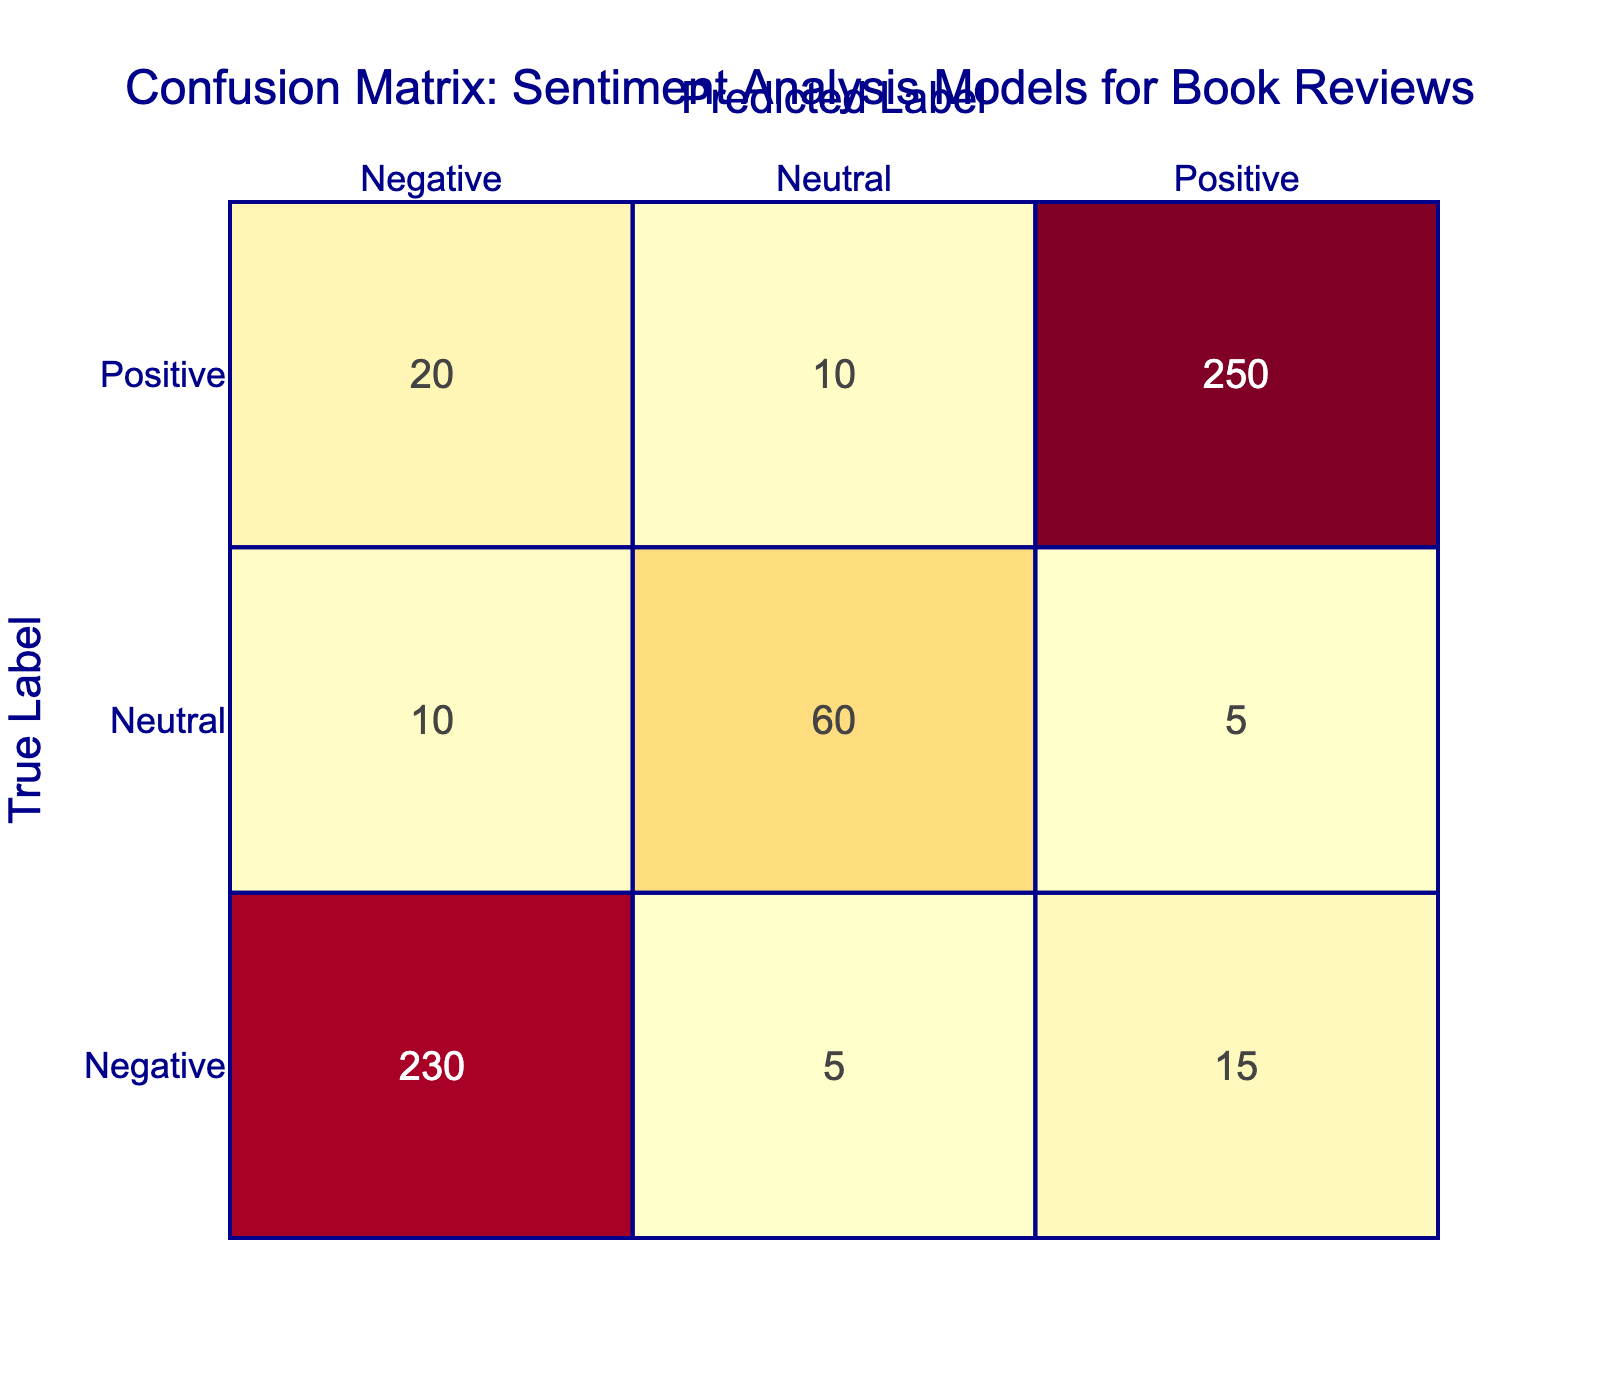What is the total number of positive predictions made? To find the total number of positive predictions, we sum the counts of all predictions labeled as positive across all true labels. This includes the counts for Positive as Positive (250), Negative as Positive (15), and Neutral as Positive (5). Therefore, the calculation is 250 + 15 + 5 = 270.
Answer: 270 How many reviews were predicted as Negative? To find the total number of reviews predicted as Negative, we sum the counts of all rows labeled as Negative in the Predicted Label column. This includes Negative as Negative (230), Positive as Negative (20), and Neutral as Negative (10). The sum is 230 + 20 + 10 = 260.
Answer: 260 What is the count of Neutral reviews that were correctly predicted? The correctly predicted Neutral reviews refer to the count where the True Label is Neutral and the Predicted Label is also Neutral. Referring to the table, this count is directly shown as 60.
Answer: 60 Is the count of Negative predictions greater than the count of Positive predictions? The counts of Negative predictions total to 260 and the counts of Positive predictions total to 270. Since 260 is not greater than 270, the answer is no.
Answer: No What percentage of Positive reviews were incorrectly classified as Negative? To find this percentage, we first identify the count of Positive reviews incorrectly predicted as Negative, which is 20. The total count of Positive reviews is 250 (correctly classified) + 20 (incorrectly classified) + 10 (neutral) = 280. The percentage is calculated as (20 / 280) * 100 = 7.14%.
Answer: 7.14% What is the difference between the number of Neutral predictions and Negative predictions? The count of Neutral predictions totals to 75 (5 Positive + 10 Negative + 60 Neutral). The count of Negative predictions is 260. To find the difference, we subtract the total count of Neutral predictions from the total count of Negative predictions: 260 - 75 = 185.
Answer: 185 How many Positive reviews were predicted to be Neutral? Checking the table, we see that Neutral predictions for Positive reviews resulted in 10 counts. This is the count of Positive reviews incorrectly predicted as Neutral.
Answer: 10 Are there more reviews that were correctly classified as Negative than those that were incorrectly classified as Positive? The number of reviews correctly classified as Negative is 230, while the number incorrectly classified as Positive is 15. Since 230 is greater than 15, the answer is yes.
Answer: Yes What is the total count of reviews categorized as Neutral? The total count of reviews categorized as Neutral includes Neutral predicted as Positive (5), Negative (10), and Neutral (60). Thus, the total is 5 + 10 + 60 = 75.
Answer: 75 